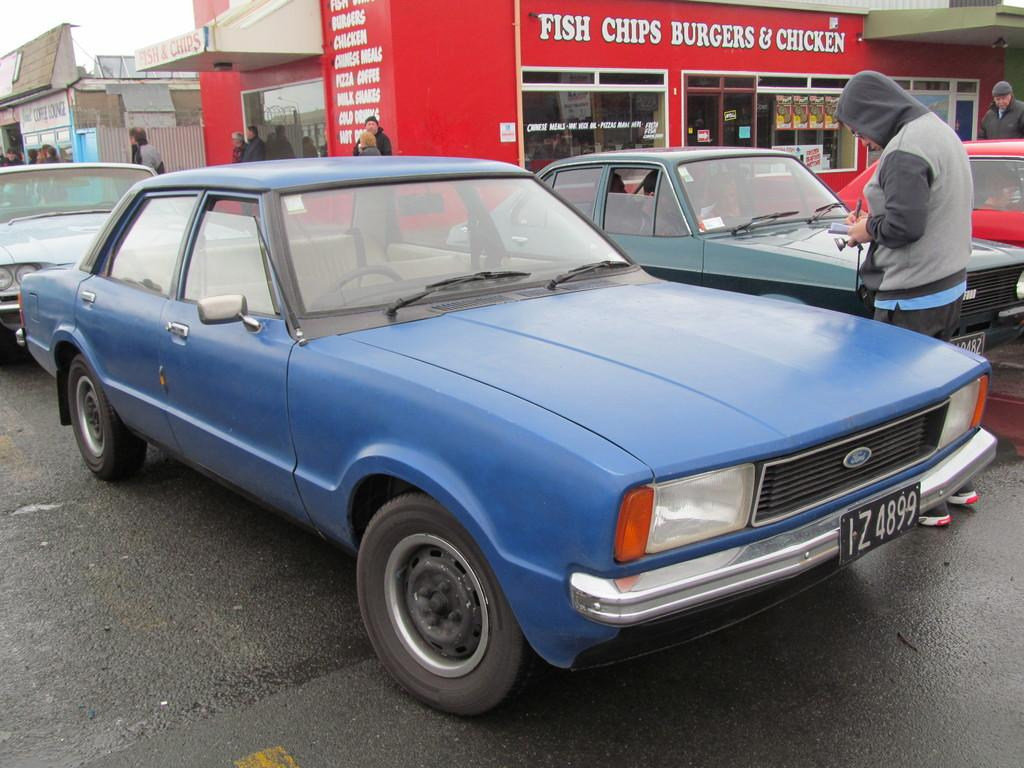<image>
Render a clear and concise summary of the photo. An older blue Ford Escort parked near a place that sells fish and chips. 